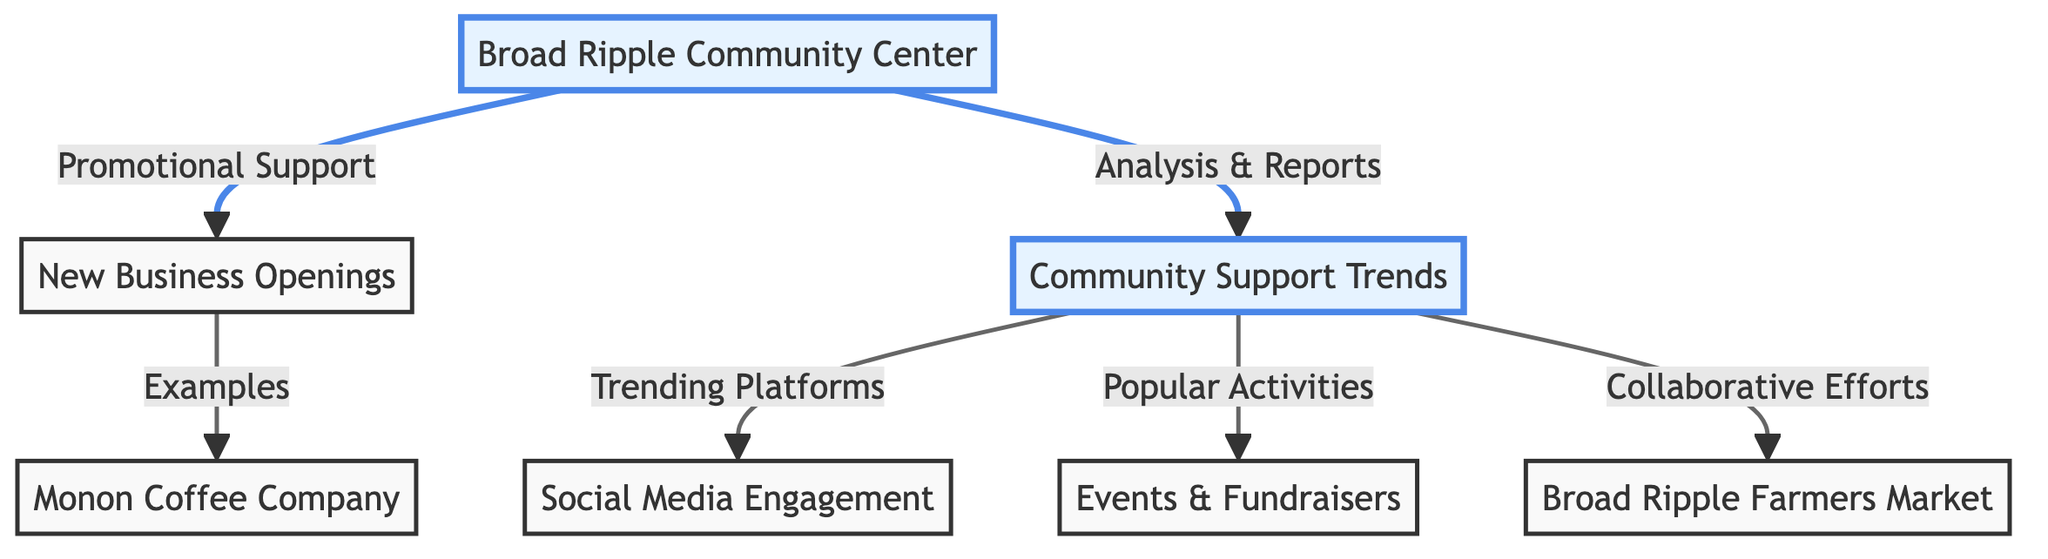What is the title of the highlighted node representing community support? The highlighted node showing community support is labeled "Community Support Trends." This can be identified as it stands out due to its color scheme and is a main point of focus in the diagram.
Answer: Community Support Trends How many new business examples are mentioned in the diagram? The diagram includes one specific example of a new business, which is "Monon Coffee Company." By analyzing the edges leading to the new business node, it is clear that it only lists one example directly.
Answer: One What is an example of a trending platform for community support? The diagram indicates "Social Media Engagement" as one of the trending platforms relating to community support trends. This relationship can be traced from the support trends node, connecting to the highlighted platform.
Answer: Social Media Engagement Name one popular activity related to community support. The diagram mentions "Events & Fundraisers" as a popular activity associated with community support trends. This is derived from the direct connection from the support trends node identifying the types of activities.
Answer: Events & Fundraisers Which node receives "Promotional Support" from the community center? The node receiving "Promotional Support" is "New Business Openings." This is found by looking at the directed edge from the community center to the new business node.
Answer: New Business Openings What type of collaborative effort is shown in the diagram? The diagram lists "Broad Ripple Farmers Market" as a collaborative effort tied to community support trends. This is seen through the connection from the support trends node to the local market node.
Answer: Broad Ripple Farmers Market How does the community center interact with community support trends? The community center provides "Analysis & Reports" to the support trends node. This can be determined by following the directed arrow from the community center to the community support trends node.
Answer: Analysis & Reports What is a potential outcome for new business openings highlighted in this diagram? The potential outcome suggested is "Promotional Support" from the community center, emphasizing how the center plays a role in promoting new businesses within the community. This can be seen as a direct relationship shown in the diagram.
Answer: Promotional Support 